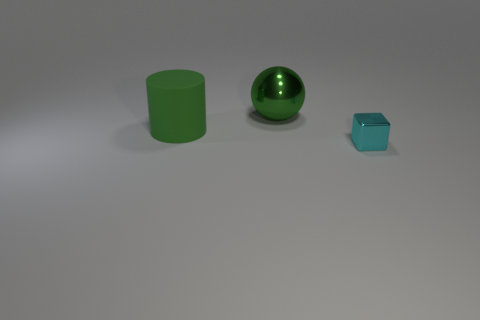Are there any other things that are the same material as the green cylinder?
Your answer should be compact. No. The object that is the same color as the large metallic ball is what shape?
Give a very brief answer. Cylinder. Is the material of the object behind the large green cylinder the same as the cyan object?
Your answer should be very brief. Yes. What material is the green object that is in front of the green thing to the right of the matte cylinder?
Offer a very short reply. Rubber. How many other objects have the same shape as the large shiny object?
Ensure brevity in your answer.  0. How big is the thing that is left of the green thing behind the large green thing in front of the green shiny sphere?
Keep it short and to the point. Large. What number of green things are metallic spheres or small metal cubes?
Offer a terse response. 1. There is a object that is in front of the large green matte thing; is its shape the same as the green matte object?
Provide a succinct answer. No. Is the number of tiny cyan things right of the green metallic ball greater than the number of big red shiny objects?
Give a very brief answer. Yes. How many rubber cylinders are the same size as the green matte object?
Keep it short and to the point. 0. 